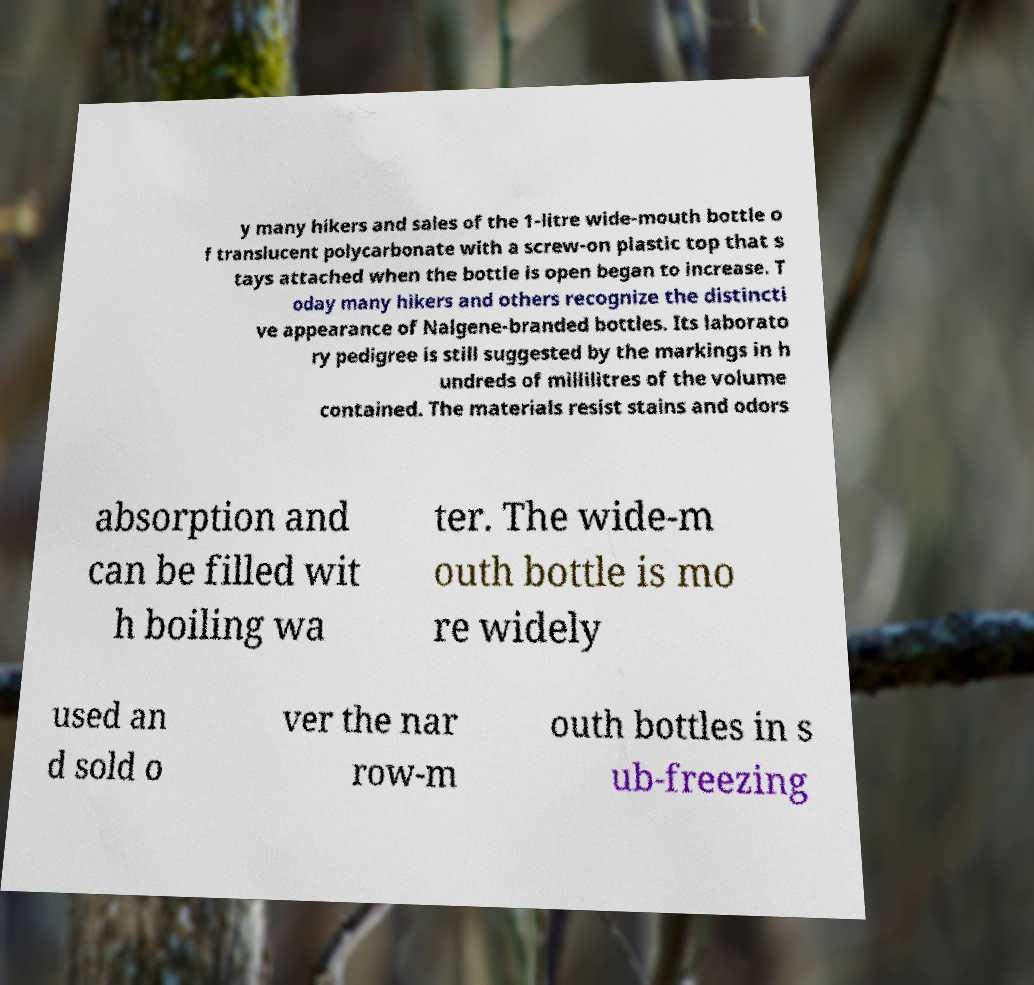Could you assist in decoding the text presented in this image and type it out clearly? y many hikers and sales of the 1-litre wide-mouth bottle o f translucent polycarbonate with a screw-on plastic top that s tays attached when the bottle is open began to increase. T oday many hikers and others recognize the distincti ve appearance of Nalgene-branded bottles. Its laborato ry pedigree is still suggested by the markings in h undreds of millilitres of the volume contained. The materials resist stains and odors absorption and can be filled wit h boiling wa ter. The wide-m outh bottle is mo re widely used an d sold o ver the nar row-m outh bottles in s ub-freezing 